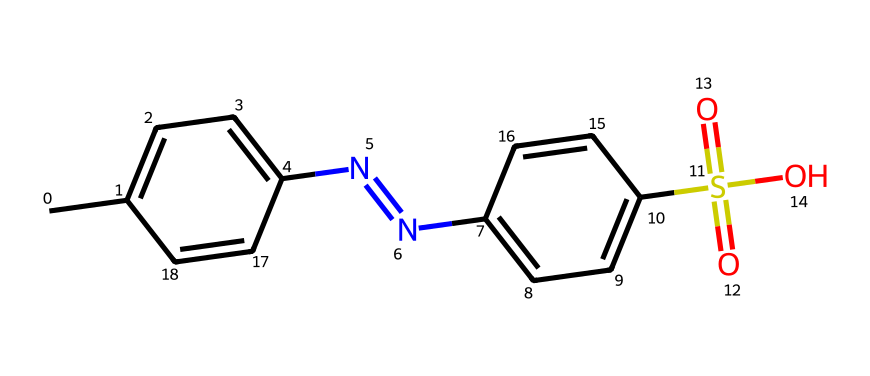What is the main functional group present in this dye? The structure contains a sulfonic acid group (-SO3H), which is the key functional group that contributes to the dye's solubility in water and its application in textiles.
Answer: sulfonic acid How many nitrogen atoms are in this chemical structure? By examining the SMILES representation, there are two nitrogen atoms present in the azo group (N=N), confirming it as a characteristic feature of azo dyes.
Answer: two What is the total number of aromatic rings in this dye? The chemical has two benzene rings that can be identified in the structure, one in the left part and one in the right part connected by the azo linkage.
Answer: two What type of dye is indicated by the presence of an azo group? Azo groups (N=N) are synonymous with azo dyes, which are known for their bright colors and are widely used in various dyeing processes.
Answer: azo dye What effect does the sulfonic acid group have on the dye's properties? The presence of the sulfonic acid group enhances the dye's solubility in water, making it suitable for dyeing applications in textiles and improving its application characteristics.
Answer: improves solubility What is the functional relationship between the two main parts of this chemical? The azo linkage (N=N) connects the two aromatic systems (rings), emphasizing the structural characteristic of azo dyes, which often consist of two aromatic compounds connected by this group.
Answer: connectivity 